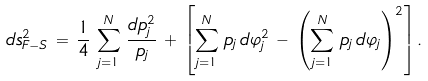<formula> <loc_0><loc_0><loc_500><loc_500>d s _ { F - S } ^ { 2 } \, = \, \frac { 1 } { 4 } \, \sum _ { j = 1 } ^ { N } \, \frac { d p _ { j } ^ { 2 } } { p _ { j } } \, + \, \left [ \sum _ { j = 1 } ^ { N } \, p _ { j } \, d \varphi _ { j } ^ { 2 } \, - \, \left ( \sum _ { j = 1 } ^ { N } \, p _ { j } \, d \varphi _ { j } \right ) ^ { 2 } \right ] .</formula> 